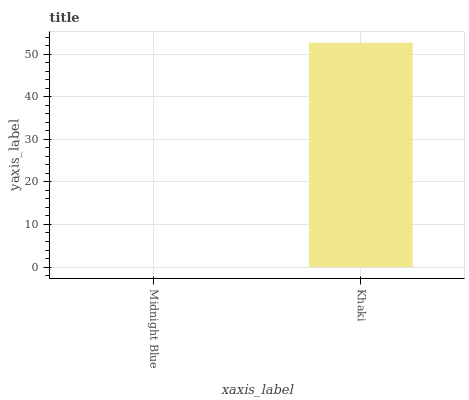Is Midnight Blue the minimum?
Answer yes or no. Yes. Is Khaki the maximum?
Answer yes or no. Yes. Is Khaki the minimum?
Answer yes or no. No. Is Khaki greater than Midnight Blue?
Answer yes or no. Yes. Is Midnight Blue less than Khaki?
Answer yes or no. Yes. Is Midnight Blue greater than Khaki?
Answer yes or no. No. Is Khaki less than Midnight Blue?
Answer yes or no. No. Is Khaki the high median?
Answer yes or no. Yes. Is Midnight Blue the low median?
Answer yes or no. Yes. Is Midnight Blue the high median?
Answer yes or no. No. Is Khaki the low median?
Answer yes or no. No. 